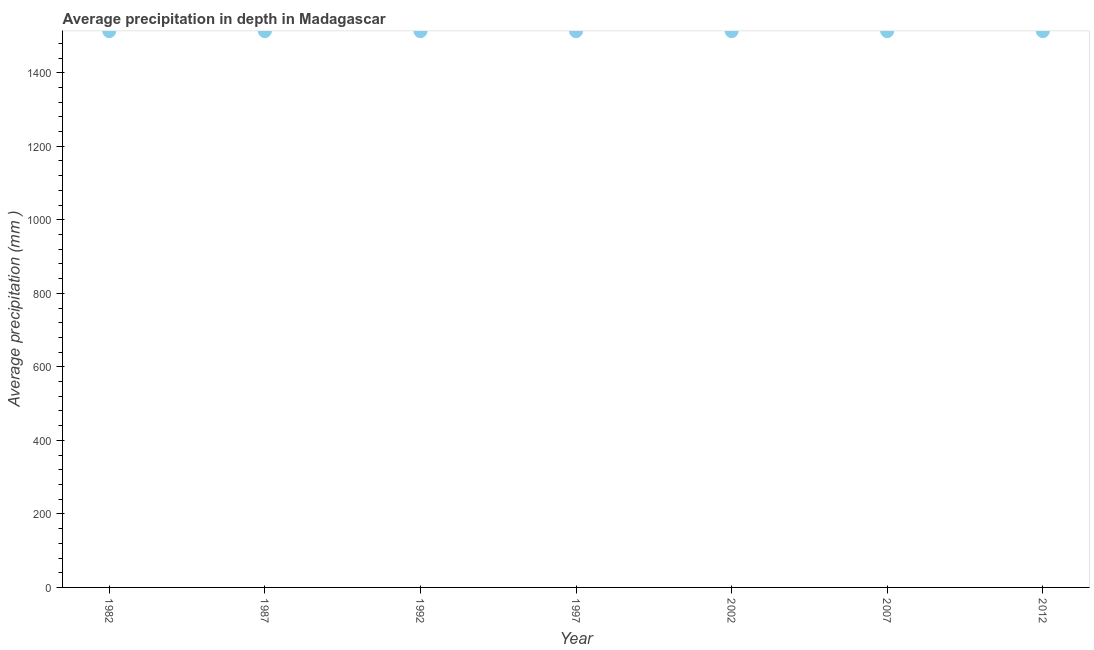What is the average precipitation in depth in 1997?
Provide a succinct answer. 1513. Across all years, what is the maximum average precipitation in depth?
Provide a succinct answer. 1513. Across all years, what is the minimum average precipitation in depth?
Your answer should be compact. 1513. What is the sum of the average precipitation in depth?
Offer a very short reply. 1.06e+04. What is the average average precipitation in depth per year?
Give a very brief answer. 1513. What is the median average precipitation in depth?
Your answer should be compact. 1513. In how many years, is the average precipitation in depth greater than 560 mm?
Provide a short and direct response. 7. Do a majority of the years between 2007 and 1987 (inclusive) have average precipitation in depth greater than 40 mm?
Keep it short and to the point. Yes. Is the average precipitation in depth in 1987 less than that in 2002?
Provide a short and direct response. No. Is the difference between the average precipitation in depth in 1982 and 2012 greater than the difference between any two years?
Your answer should be compact. Yes. What is the difference between the highest and the lowest average precipitation in depth?
Your answer should be very brief. 0. How many dotlines are there?
Offer a very short reply. 1. How many years are there in the graph?
Provide a short and direct response. 7. What is the difference between two consecutive major ticks on the Y-axis?
Offer a very short reply. 200. What is the title of the graph?
Give a very brief answer. Average precipitation in depth in Madagascar. What is the label or title of the X-axis?
Make the answer very short. Year. What is the label or title of the Y-axis?
Ensure brevity in your answer.  Average precipitation (mm ). What is the Average precipitation (mm ) in 1982?
Keep it short and to the point. 1513. What is the Average precipitation (mm ) in 1987?
Your answer should be very brief. 1513. What is the Average precipitation (mm ) in 1992?
Your answer should be very brief. 1513. What is the Average precipitation (mm ) in 1997?
Your answer should be compact. 1513. What is the Average precipitation (mm ) in 2002?
Provide a short and direct response. 1513. What is the Average precipitation (mm ) in 2007?
Offer a terse response. 1513. What is the Average precipitation (mm ) in 2012?
Keep it short and to the point. 1513. What is the difference between the Average precipitation (mm ) in 1982 and 1987?
Your response must be concise. 0. What is the difference between the Average precipitation (mm ) in 1982 and 1992?
Your response must be concise. 0. What is the difference between the Average precipitation (mm ) in 1982 and 2007?
Give a very brief answer. 0. What is the difference between the Average precipitation (mm ) in 1982 and 2012?
Provide a succinct answer. 0. What is the difference between the Average precipitation (mm ) in 1987 and 1997?
Make the answer very short. 0. What is the difference between the Average precipitation (mm ) in 1987 and 2002?
Give a very brief answer. 0. What is the difference between the Average precipitation (mm ) in 1987 and 2007?
Your answer should be very brief. 0. What is the difference between the Average precipitation (mm ) in 1992 and 1997?
Provide a succinct answer. 0. What is the difference between the Average precipitation (mm ) in 1992 and 2002?
Provide a short and direct response. 0. What is the difference between the Average precipitation (mm ) in 1997 and 2007?
Make the answer very short. 0. What is the difference between the Average precipitation (mm ) in 2002 and 2007?
Give a very brief answer. 0. What is the difference between the Average precipitation (mm ) in 2002 and 2012?
Your answer should be compact. 0. What is the difference between the Average precipitation (mm ) in 2007 and 2012?
Make the answer very short. 0. What is the ratio of the Average precipitation (mm ) in 1982 to that in 1987?
Offer a terse response. 1. What is the ratio of the Average precipitation (mm ) in 1982 to that in 2002?
Provide a short and direct response. 1. What is the ratio of the Average precipitation (mm ) in 1982 to that in 2007?
Offer a very short reply. 1. What is the ratio of the Average precipitation (mm ) in 1982 to that in 2012?
Offer a very short reply. 1. What is the ratio of the Average precipitation (mm ) in 1987 to that in 1992?
Provide a short and direct response. 1. What is the ratio of the Average precipitation (mm ) in 1987 to that in 2002?
Your answer should be compact. 1. What is the ratio of the Average precipitation (mm ) in 1987 to that in 2012?
Offer a terse response. 1. What is the ratio of the Average precipitation (mm ) in 1992 to that in 1997?
Ensure brevity in your answer.  1. What is the ratio of the Average precipitation (mm ) in 1992 to that in 2007?
Ensure brevity in your answer.  1. What is the ratio of the Average precipitation (mm ) in 1997 to that in 2002?
Offer a very short reply. 1. What is the ratio of the Average precipitation (mm ) in 1997 to that in 2007?
Your answer should be compact. 1. What is the ratio of the Average precipitation (mm ) in 2002 to that in 2007?
Ensure brevity in your answer.  1. What is the ratio of the Average precipitation (mm ) in 2007 to that in 2012?
Make the answer very short. 1. 